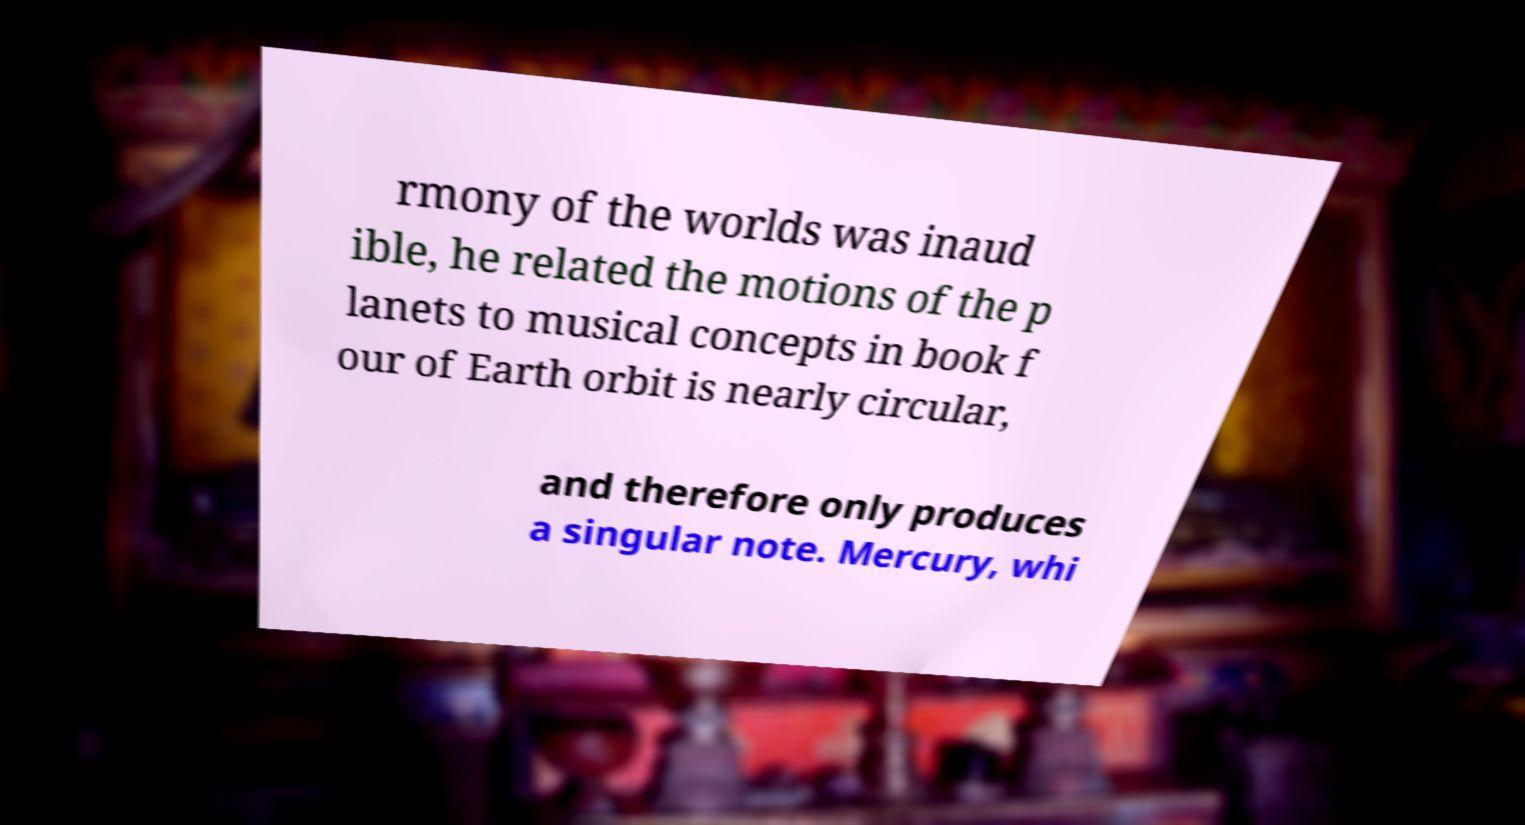Could you assist in decoding the text presented in this image and type it out clearly? rmony of the worlds was inaud ible, he related the motions of the p lanets to musical concepts in book f our of Earth orbit is nearly circular, and therefore only produces a singular note. Mercury, whi 